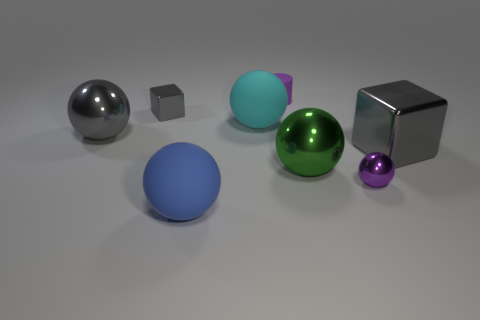Subtract all gray metal spheres. How many spheres are left? 4 Subtract 2 spheres. How many spheres are left? 3 Subtract all green spheres. How many spheres are left? 4 Subtract all yellow balls. Subtract all gray cubes. How many balls are left? 5 Add 1 small rubber cylinders. How many objects exist? 9 Subtract all cylinders. How many objects are left? 7 Add 5 tiny purple metal balls. How many tiny purple metal balls exist? 6 Subtract 0 yellow cylinders. How many objects are left? 8 Subtract all purple things. Subtract all big green shiny spheres. How many objects are left? 5 Add 6 small purple balls. How many small purple balls are left? 7 